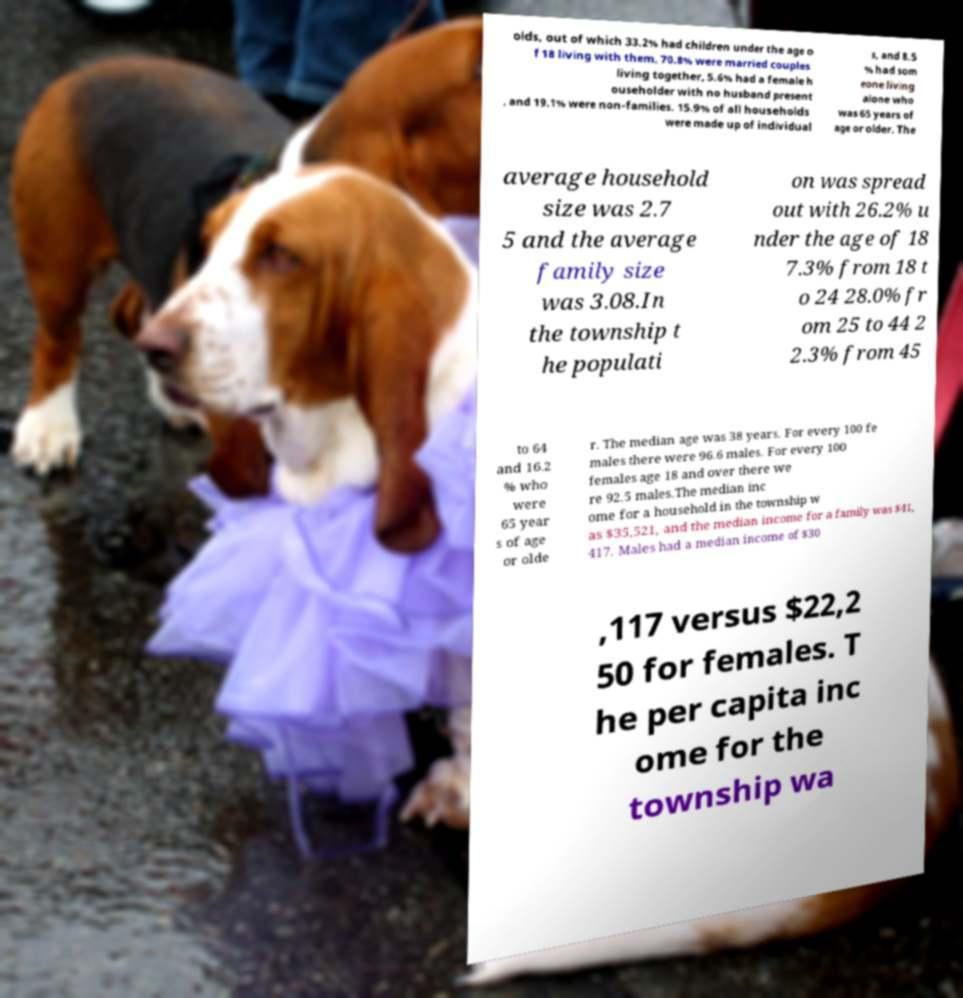What messages or text are displayed in this image? I need them in a readable, typed format. olds, out of which 33.2% had children under the age o f 18 living with them, 70.8% were married couples living together, 5.6% had a female h ouseholder with no husband present , and 19.1% were non-families. 15.9% of all households were made up of individual s, and 8.5 % had som eone living alone who was 65 years of age or older. The average household size was 2.7 5 and the average family size was 3.08.In the township t he populati on was spread out with 26.2% u nder the age of 18 7.3% from 18 t o 24 28.0% fr om 25 to 44 2 2.3% from 45 to 64 and 16.2 % who were 65 year s of age or olde r. The median age was 38 years. For every 100 fe males there were 96.6 males. For every 100 females age 18 and over there we re 92.5 males.The median inc ome for a household in the township w as $35,521, and the median income for a family was $41, 417. Males had a median income of $30 ,117 versus $22,2 50 for females. T he per capita inc ome for the township wa 